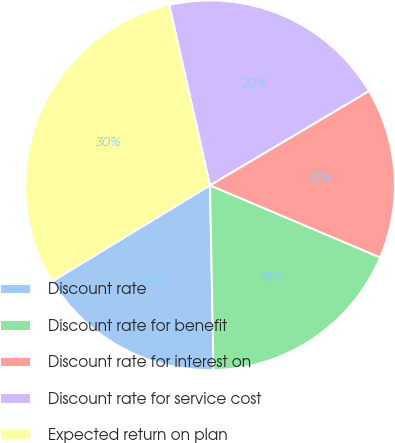<chart> <loc_0><loc_0><loc_500><loc_500><pie_chart><fcel>Discount rate<fcel>Discount rate for benefit<fcel>Discount rate for interest on<fcel>Discount rate for service cost<fcel>Expected return on plan<nl><fcel>16.6%<fcel>18.31%<fcel>14.9%<fcel>20.02%<fcel>30.17%<nl></chart> 